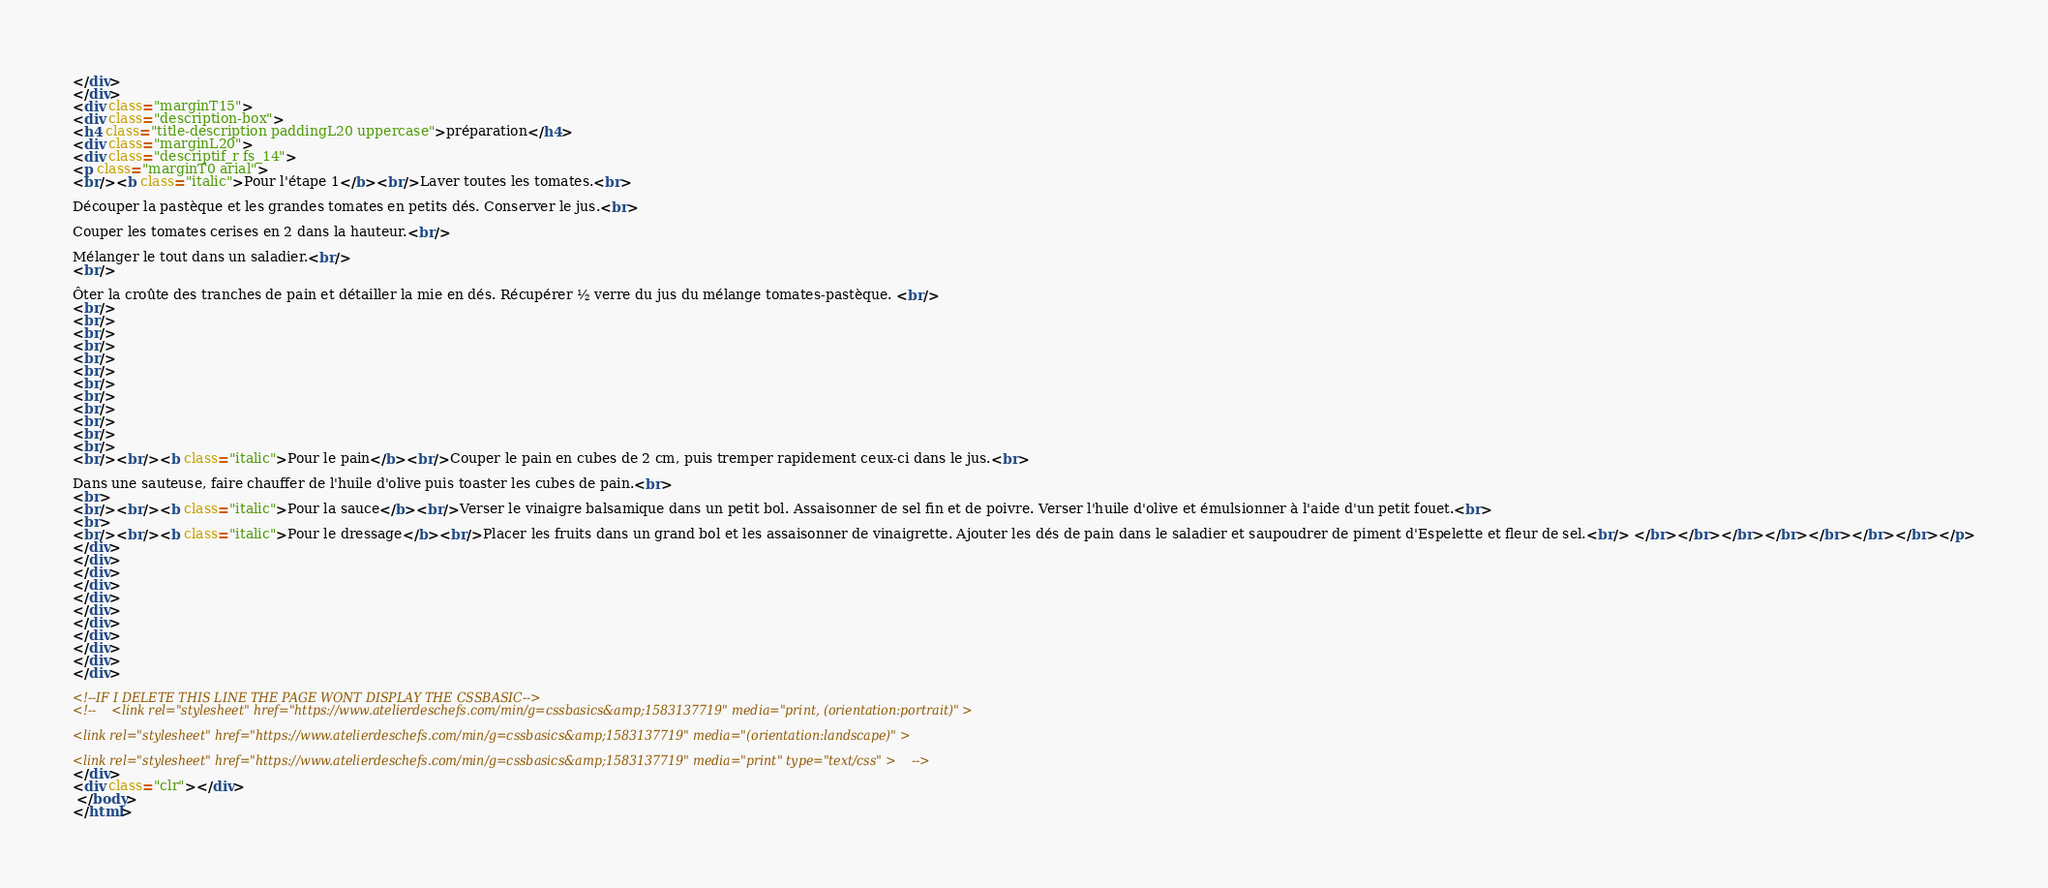Convert code to text. <code><loc_0><loc_0><loc_500><loc_500><_HTML_></div>
</div>
<div class="marginT15">
<div class="description-box">
<h4 class="title-description paddingL20 uppercase">préparation</h4>
<div class="marginL20">
<div class="descriptif_r fs_14">
<p class="marginT0 arial">
<br/><b class="italic">Pour l'étape 1</b><br/>Laver toutes les tomates.<br>
Découper la pastèque et les grandes tomates en petits dés. Conserver le jus.<br>
Couper les tomates cerises en 2 dans la hauteur.<br/>
Mélanger le tout dans un saladier.<br/>
<br/>
Ôter la croûte des tranches de pain et détailler la mie en dés. Récupérer ½ verre du jus du mélange tomates-pastèque. <br/>
<br/>
<br/>
<br/>
<br/>
<br/>
<br/>
<br/>
<br/>
<br/>
<br/>
<br/>
<br/>
<br/><br/><b class="italic">Pour le pain</b><br/>Couper le pain en cubes de 2 cm, puis tremper rapidement ceux-ci dans le jus.<br>
Dans une sauteuse, faire chauffer de l'huile d'olive puis toaster les cubes de pain.<br>
<br>
<br/><br/><b class="italic">Pour la sauce</b><br/>Verser le vinaigre balsamique dans un petit bol. Assaisonner de sel fin et de poivre. Verser l'huile d'olive et émulsionner à l'aide d'un petit fouet.<br>
<br>
<br/><br/><b class="italic">Pour le dressage</b><br/>Placer les fruits dans un grand bol et les assaisonner de vinaigrette. Ajouter les dés de pain dans le saladier et saupoudrer de piment d'Espelette et fleur de sel.<br/> </br></br></br></br></br></br></br></p>
</div>
</div>
</div>
</div>
</div>
</div>
</div>
</div>
</div>
</div>
</div>

<!--IF I DELETE THIS LINE THE PAGE WONT DISPLAY THE CSSBASIC-->
<!--    <link rel="stylesheet" href="https://www.atelierdeschefs.com/min/g=cssbasics&amp;1583137719" media="print, (orientation:portrait)" >    
<link rel="stylesheet" href="https://www.atelierdeschefs.com/min/g=cssbasics&amp;1583137719" media="(orientation:landscape)" >    
<link rel="stylesheet" href="https://www.atelierdeschefs.com/min/g=cssbasics&amp;1583137719" media="print" type="text/css" >    -->
</div>
<div class="clr"></div>
 </body>
</html></code> 